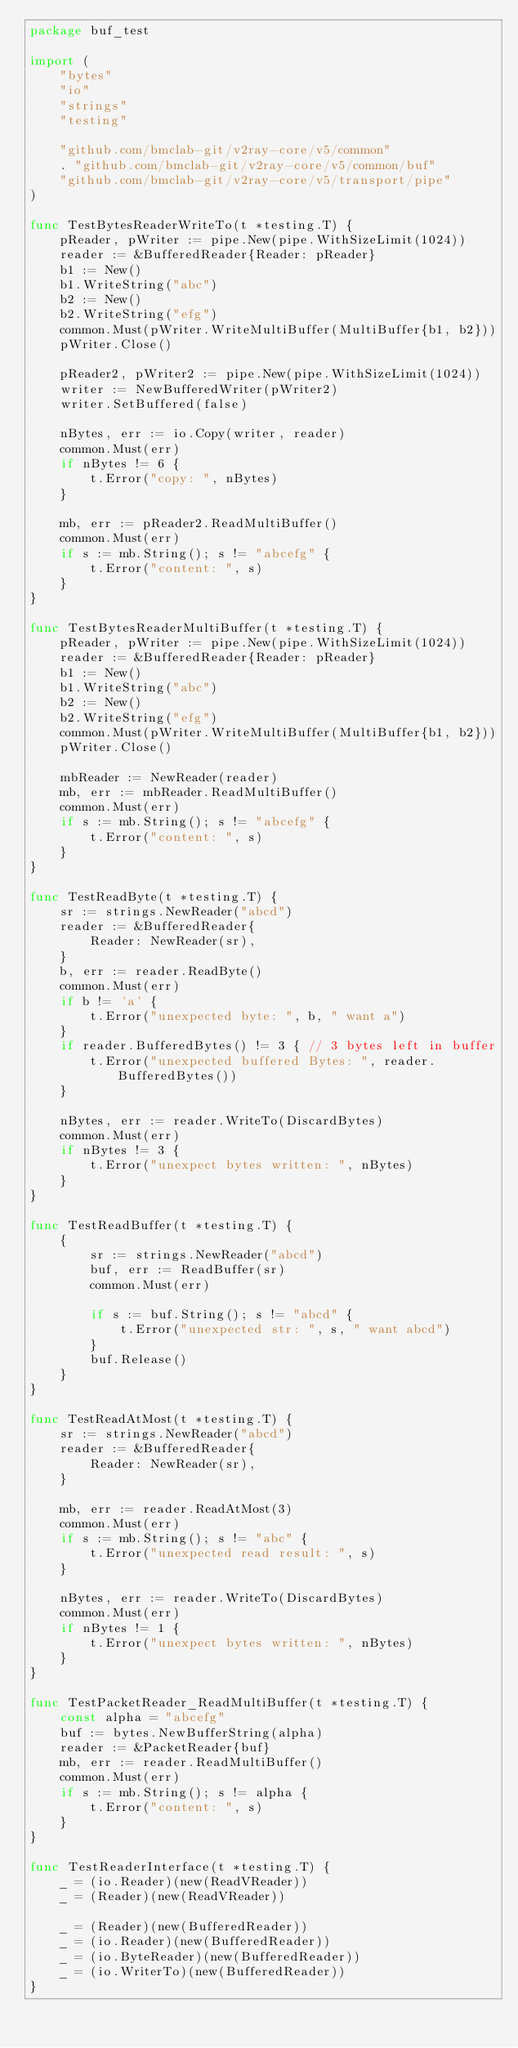<code> <loc_0><loc_0><loc_500><loc_500><_Go_>package buf_test

import (
	"bytes"
	"io"
	"strings"
	"testing"

	"github.com/bmclab-git/v2ray-core/v5/common"
	. "github.com/bmclab-git/v2ray-core/v5/common/buf"
	"github.com/bmclab-git/v2ray-core/v5/transport/pipe"
)

func TestBytesReaderWriteTo(t *testing.T) {
	pReader, pWriter := pipe.New(pipe.WithSizeLimit(1024))
	reader := &BufferedReader{Reader: pReader}
	b1 := New()
	b1.WriteString("abc")
	b2 := New()
	b2.WriteString("efg")
	common.Must(pWriter.WriteMultiBuffer(MultiBuffer{b1, b2}))
	pWriter.Close()

	pReader2, pWriter2 := pipe.New(pipe.WithSizeLimit(1024))
	writer := NewBufferedWriter(pWriter2)
	writer.SetBuffered(false)

	nBytes, err := io.Copy(writer, reader)
	common.Must(err)
	if nBytes != 6 {
		t.Error("copy: ", nBytes)
	}

	mb, err := pReader2.ReadMultiBuffer()
	common.Must(err)
	if s := mb.String(); s != "abcefg" {
		t.Error("content: ", s)
	}
}

func TestBytesReaderMultiBuffer(t *testing.T) {
	pReader, pWriter := pipe.New(pipe.WithSizeLimit(1024))
	reader := &BufferedReader{Reader: pReader}
	b1 := New()
	b1.WriteString("abc")
	b2 := New()
	b2.WriteString("efg")
	common.Must(pWriter.WriteMultiBuffer(MultiBuffer{b1, b2}))
	pWriter.Close()

	mbReader := NewReader(reader)
	mb, err := mbReader.ReadMultiBuffer()
	common.Must(err)
	if s := mb.String(); s != "abcefg" {
		t.Error("content: ", s)
	}
}

func TestReadByte(t *testing.T) {
	sr := strings.NewReader("abcd")
	reader := &BufferedReader{
		Reader: NewReader(sr),
	}
	b, err := reader.ReadByte()
	common.Must(err)
	if b != 'a' {
		t.Error("unexpected byte: ", b, " want a")
	}
	if reader.BufferedBytes() != 3 { // 3 bytes left in buffer
		t.Error("unexpected buffered Bytes: ", reader.BufferedBytes())
	}

	nBytes, err := reader.WriteTo(DiscardBytes)
	common.Must(err)
	if nBytes != 3 {
		t.Error("unexpect bytes written: ", nBytes)
	}
}

func TestReadBuffer(t *testing.T) {
	{
		sr := strings.NewReader("abcd")
		buf, err := ReadBuffer(sr)
		common.Must(err)

		if s := buf.String(); s != "abcd" {
			t.Error("unexpected str: ", s, " want abcd")
		}
		buf.Release()
	}
}

func TestReadAtMost(t *testing.T) {
	sr := strings.NewReader("abcd")
	reader := &BufferedReader{
		Reader: NewReader(sr),
	}

	mb, err := reader.ReadAtMost(3)
	common.Must(err)
	if s := mb.String(); s != "abc" {
		t.Error("unexpected read result: ", s)
	}

	nBytes, err := reader.WriteTo(DiscardBytes)
	common.Must(err)
	if nBytes != 1 {
		t.Error("unexpect bytes written: ", nBytes)
	}
}

func TestPacketReader_ReadMultiBuffer(t *testing.T) {
	const alpha = "abcefg"
	buf := bytes.NewBufferString(alpha)
	reader := &PacketReader{buf}
	mb, err := reader.ReadMultiBuffer()
	common.Must(err)
	if s := mb.String(); s != alpha {
		t.Error("content: ", s)
	}
}

func TestReaderInterface(t *testing.T) {
	_ = (io.Reader)(new(ReadVReader))
	_ = (Reader)(new(ReadVReader))

	_ = (Reader)(new(BufferedReader))
	_ = (io.Reader)(new(BufferedReader))
	_ = (io.ByteReader)(new(BufferedReader))
	_ = (io.WriterTo)(new(BufferedReader))
}
</code> 